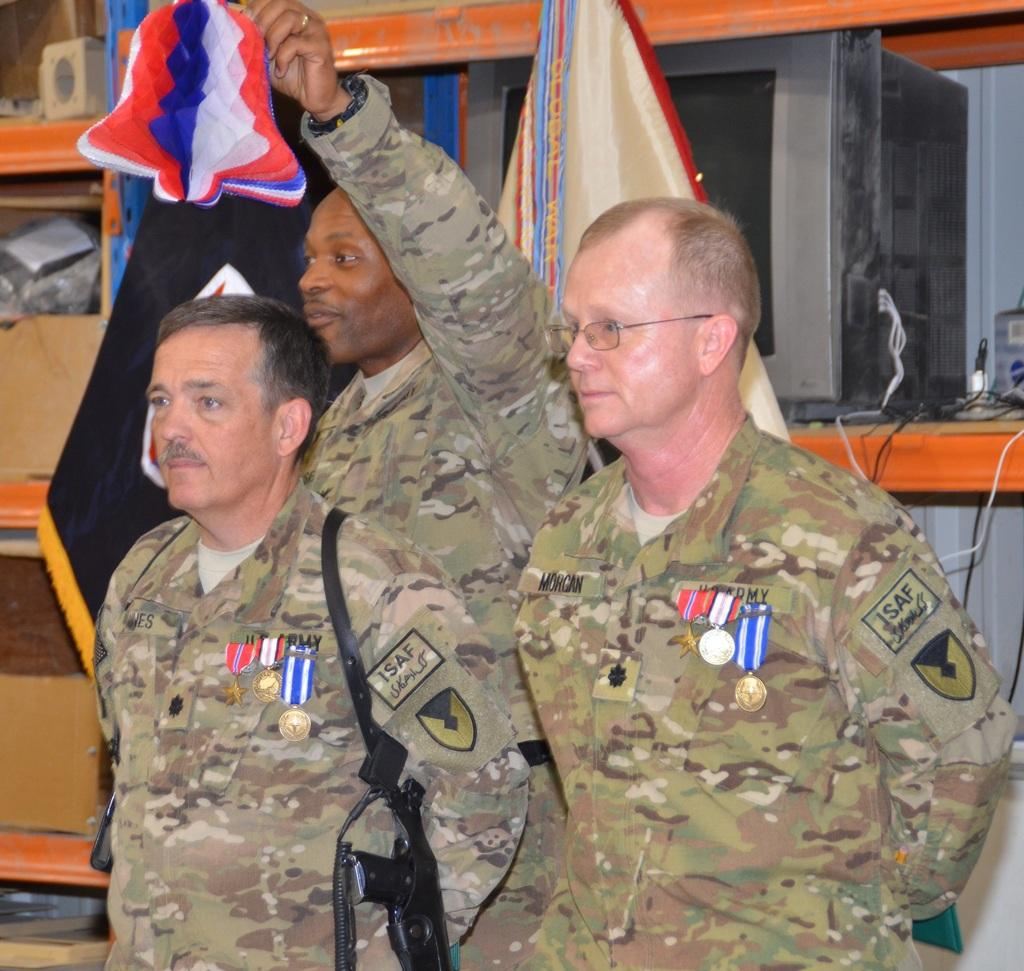What are the persons in the image wearing? The persons in the image are wearing uniforms. What are the persons in the image doing? The persons are standing. What is one person holding in the image? One person is holding decorative papers with one hand. What can be seen in the background of the image? There are flags and other objects in the background of the image. What type of flower is being used as a prop in the image? There is no flower present in the image. What type of competition are the persons participating in, as seen in the image? The image does not provide any information about a competition. 